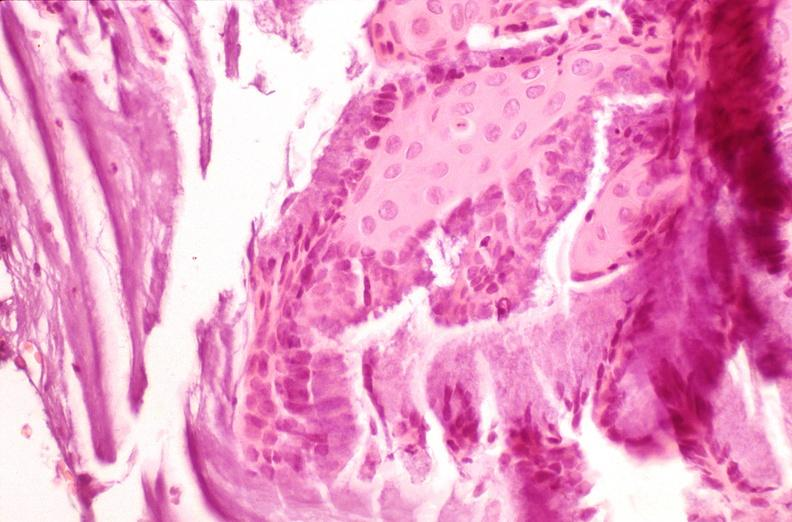where is this from?
Answer the question using a single word or phrase. Female reproductive system 